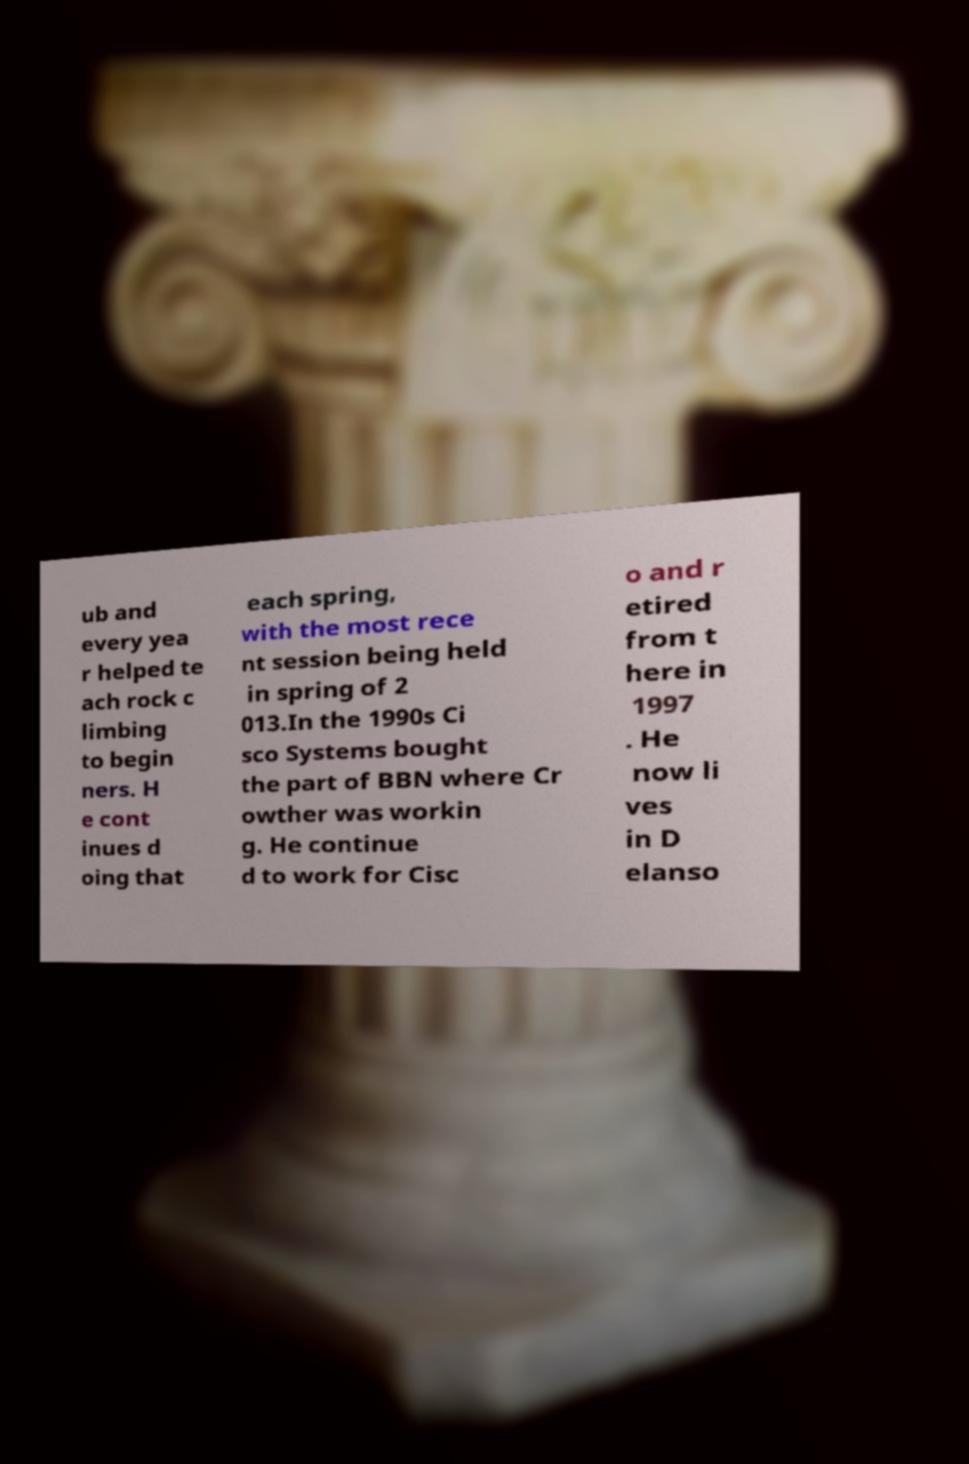Can you accurately transcribe the text from the provided image for me? ub and every yea r helped te ach rock c limbing to begin ners. H e cont inues d oing that each spring, with the most rece nt session being held in spring of 2 013.In the 1990s Ci sco Systems bought the part of BBN where Cr owther was workin g. He continue d to work for Cisc o and r etired from t here in 1997 . He now li ves in D elanso 